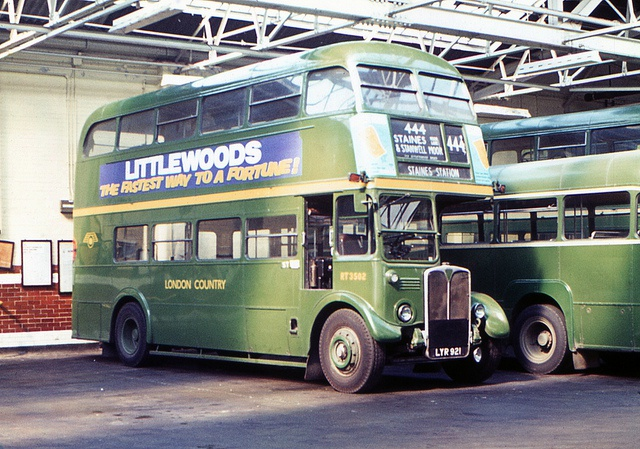Describe the objects in this image and their specific colors. I can see bus in black, gray, white, and tan tones and bus in black, gray, and olive tones in this image. 